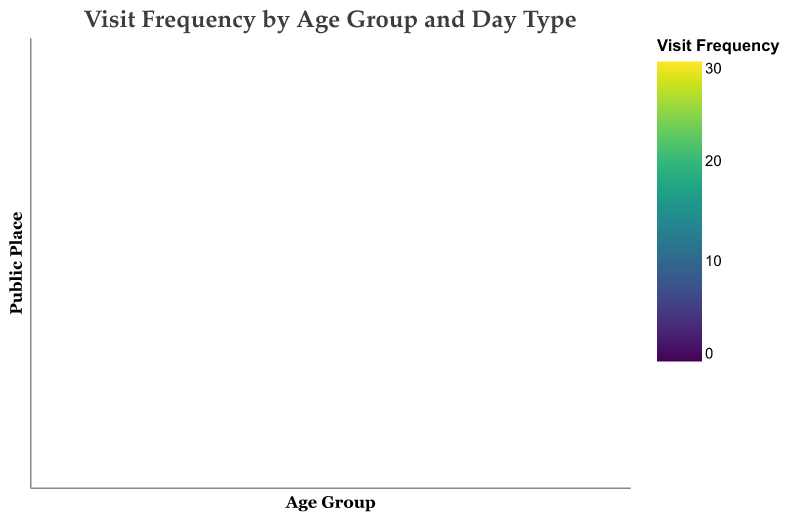How does the visit frequency to the City Library during weekdays compare across different age groups? To answer this, look at the color gradient in the column for "Weekday Frequency" for each age group under the row "City Library". The colors indicate that the 31-40 age group visits most frequently, followed by 20-30, 41-50, 51-60, 61-70, and then 71+.
Answer: The 31-40 age group visits the most, followed by 20-30 In which age group is there the largest difference in visit frequencies between weekdays and weekends for Central Park? Compare the difference in color intensity between the "Weekday Frequency" and "Weekend Frequency" columns in the row for Central Park for each age group. The 20-30 age group shows the largest color difference.
Answer: 20-30 How do visit frequencies to the Fitness Center change during weekdays and weekends for the 61-70 age group? Compare the color in the "Frequency" column for "Weekday Frequency" and "Weekend Frequency" under the row for "Fitness Center" and age group 61-70. The weekday color is lighter than the weekend, indicating a lower frequency.
Answer: Lower during weekdays, higher during weekends Which place has the highest visit frequency for the 71+ age group during weekends? Look for the deepest color intensity under the "Weekend Frequency" column across all places for the 71+ age group. The darkest color is in the "Central Park" row.
Answer: Central Park What is the average visit frequency across all age groups to the Shopping Mall during weekdays? Sum the weekday frequencies: 20 (20-30) + 18 (31-40) + 15 (41-50) + 12 (51-60) + 10 (61-70) + 8 (71+) = 83, then divide by 6 age groups.
Answer: 13.83 What can we infer about the visit patterns to public places for the 20-30 age group? Observe the color intensities in both "Weekday Frequency" and "Weekend Frequency" columns for 20-30 across all places. The Shopping Mall has the highest weekend frequency, followed by Central Park and the Fitness Center. Weekday frequencies are highest for Shopping Mall and Fitness Center.
Answer: High visits to Shopping Mall and Fitness Center on both weekdays and weekends Which place has the most uniform visit frequency distribution across all age groups during weekends? Compare the color distribution in the "Weekend Frequency" column for each place. The color differences are least in the City Library, indicating a more uniform distribution.
Answer: City Library Is there a trend in visit frequency to Community Center based on age during weekends? Examine the "Weekend Frequency" column for the Community Center row. The color lightens progressively from younger to older age groups. This indicates a trend of decreasing visit frequency with increasing age.
Answer: Decreases with age 